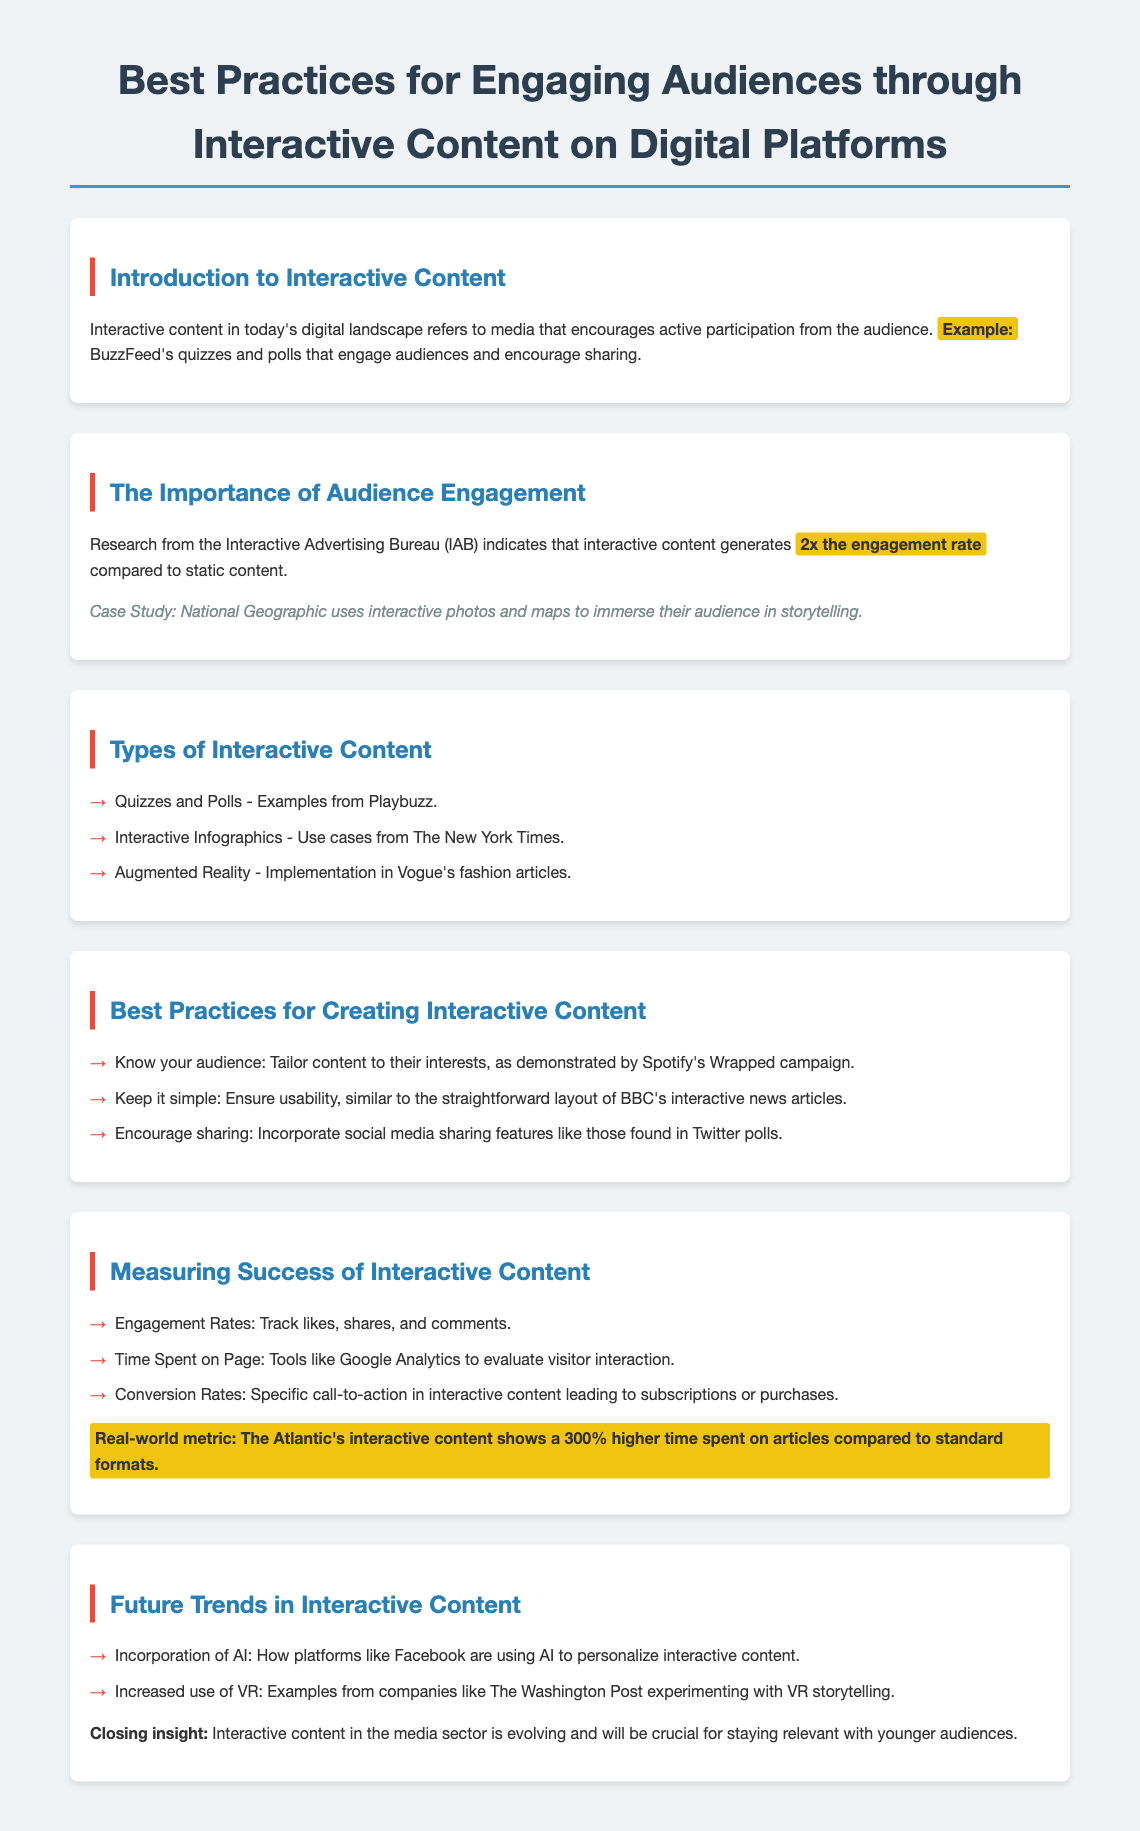What is interactive content? Interactive content is defined in the document as media that encourages active participation from the audience.
Answer: Media that encourages active participation What engagement rate does interactive content generate compared to static content? The document states that interactive content generates 2x the engagement rate.
Answer: 2x Which publication uses interactive photos and maps? The case study within the document mentions National Geographic using interactive photos and maps.
Answer: National Geographic What is an example of a quiz platform mentioned? The document lists Playbuzz as an example of a quiz platform.
Answer: Playbuzz What is a best practice for creating interactive content? The document advises to tailor content to audience interests, as demonstrated by Spotify's Wrapped campaign.
Answer: Tailor content to audience interests What metric shows a 300% higher time spent on articles? The document states that The Atlantic's interactive content shows a 300% higher time spent.
Answer: The Atlantic What future trend involves companies experimenting with storytelling? The document describes increased use of VR with companies like The Washington Post experimenting with VR storytelling.
Answer: Increased use of VR How does the document suggest measuring engagement? It suggests tracking likes, shares, and comments as a method of measurement.
Answer: Likes, shares, and comments What color is used for the best practices section heading? The color listed for the best practices section heading is highlighted in the document.
Answer: #2980b9 